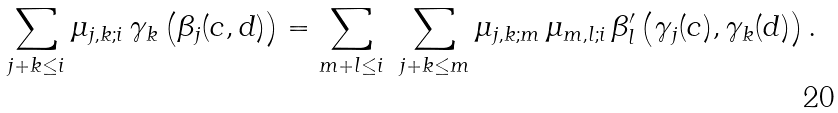<formula> <loc_0><loc_0><loc_500><loc_500>\sum _ { j + k \leq i } \mu _ { j , k ; i } \, \gamma _ { k } \left ( \beta _ { j } ( c , d ) \right ) = \sum _ { m + l \leq i } \ \sum _ { j + k \leq m } \mu _ { j , k ; m } \, \mu _ { m , l ; i } \, \beta ^ { \prime } _ { l } \left ( \gamma _ { j } ( c ) , \gamma _ { k } ( d ) \right ) .</formula> 